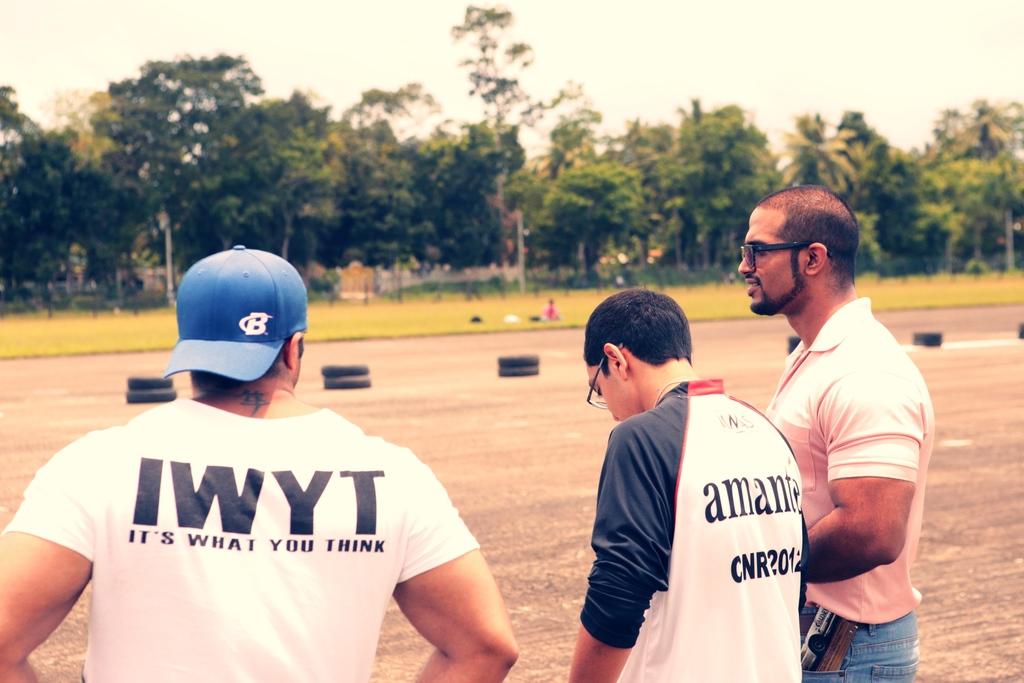What letter is on the blue hat?
Keep it short and to the point. B. What does the mans shirt say on the very left?
Provide a short and direct response. It's what you think. 